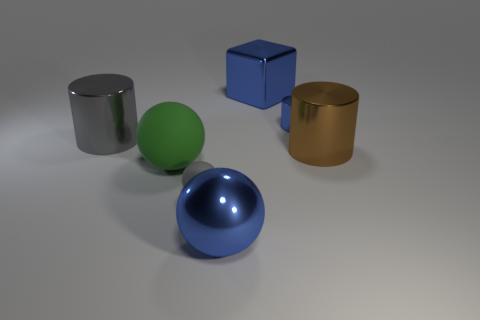Add 1 brown metallic objects. How many objects exist? 8 Subtract all cubes. How many objects are left? 6 Add 7 gray matte balls. How many gray matte balls exist? 8 Subtract 0 cyan cylinders. How many objects are left? 7 Subtract all large matte objects. Subtract all large shiny balls. How many objects are left? 5 Add 7 small gray matte balls. How many small gray matte balls are left? 8 